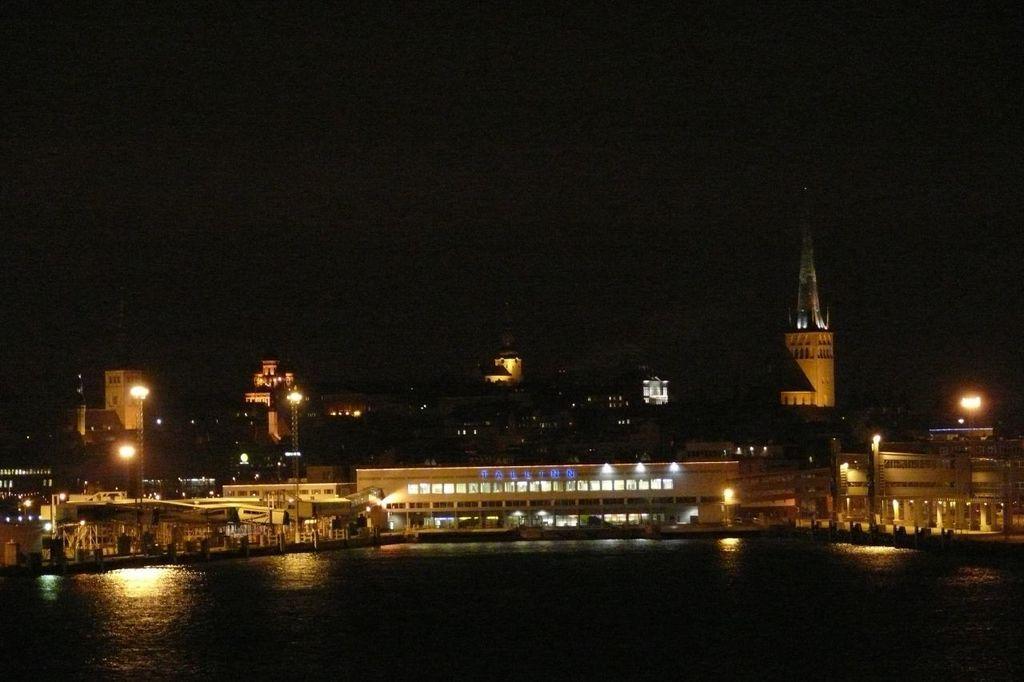Can you describe this image briefly? In this image we can see the building with lights and in front of the building we can see the water and dark background. 